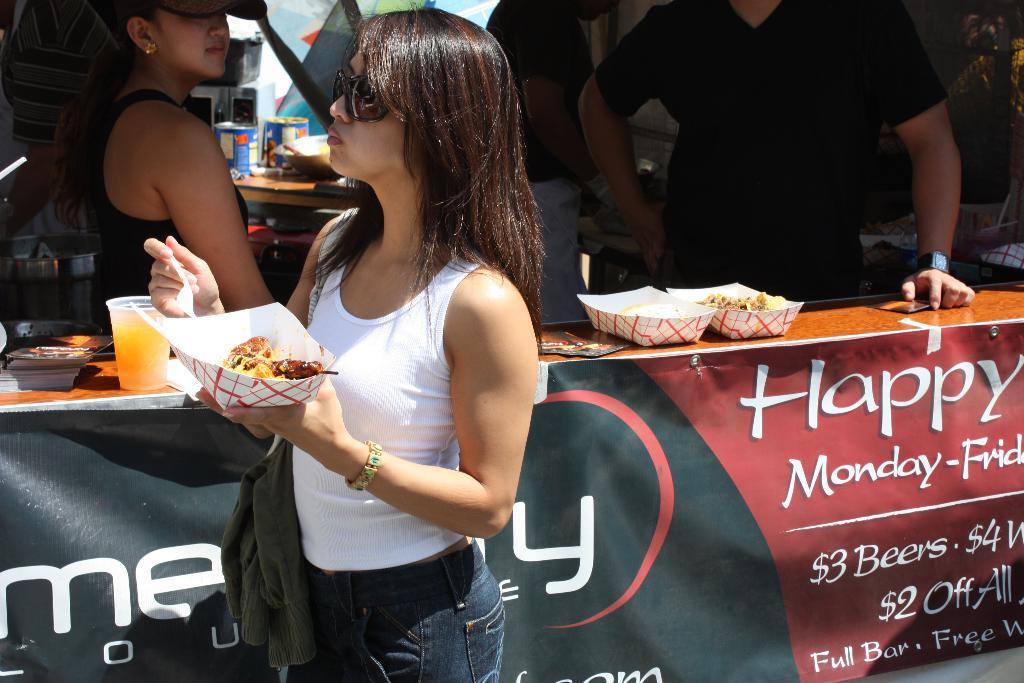Please provide a concise description of this image. In this image I can see four persons are standing on the floor in front of a table on which I can see glasses, vessels, cans and food items. This image is taken during a day near the food truck. 